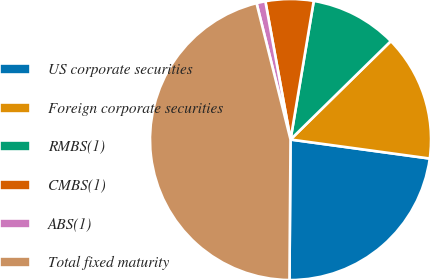<chart> <loc_0><loc_0><loc_500><loc_500><pie_chart><fcel>US corporate securities<fcel>Foreign corporate securities<fcel>RMBS(1)<fcel>CMBS(1)<fcel>ABS(1)<fcel>Total fixed maturity<nl><fcel>22.96%<fcel>14.51%<fcel>10.01%<fcel>5.51%<fcel>1.02%<fcel>45.99%<nl></chart> 